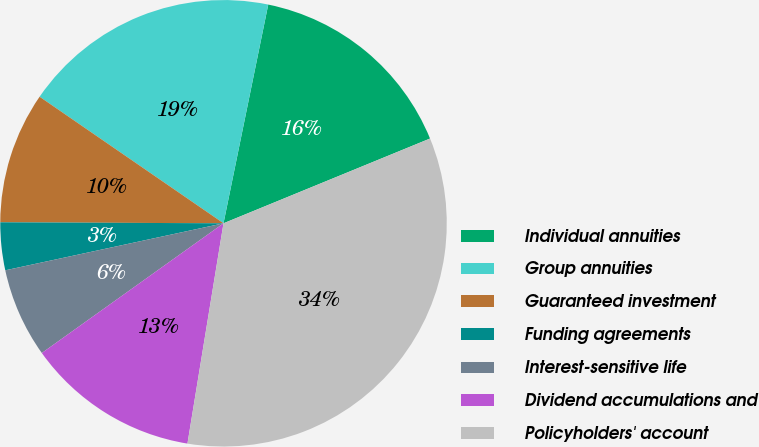Convert chart to OTSL. <chart><loc_0><loc_0><loc_500><loc_500><pie_chart><fcel>Individual annuities<fcel>Group annuities<fcel>Guaranteed investment<fcel>Funding agreements<fcel>Interest-sensitive life<fcel>Dividend accumulations and<fcel>Policyholders' account<nl><fcel>15.59%<fcel>18.62%<fcel>9.52%<fcel>3.45%<fcel>6.49%<fcel>12.55%<fcel>33.78%<nl></chart> 